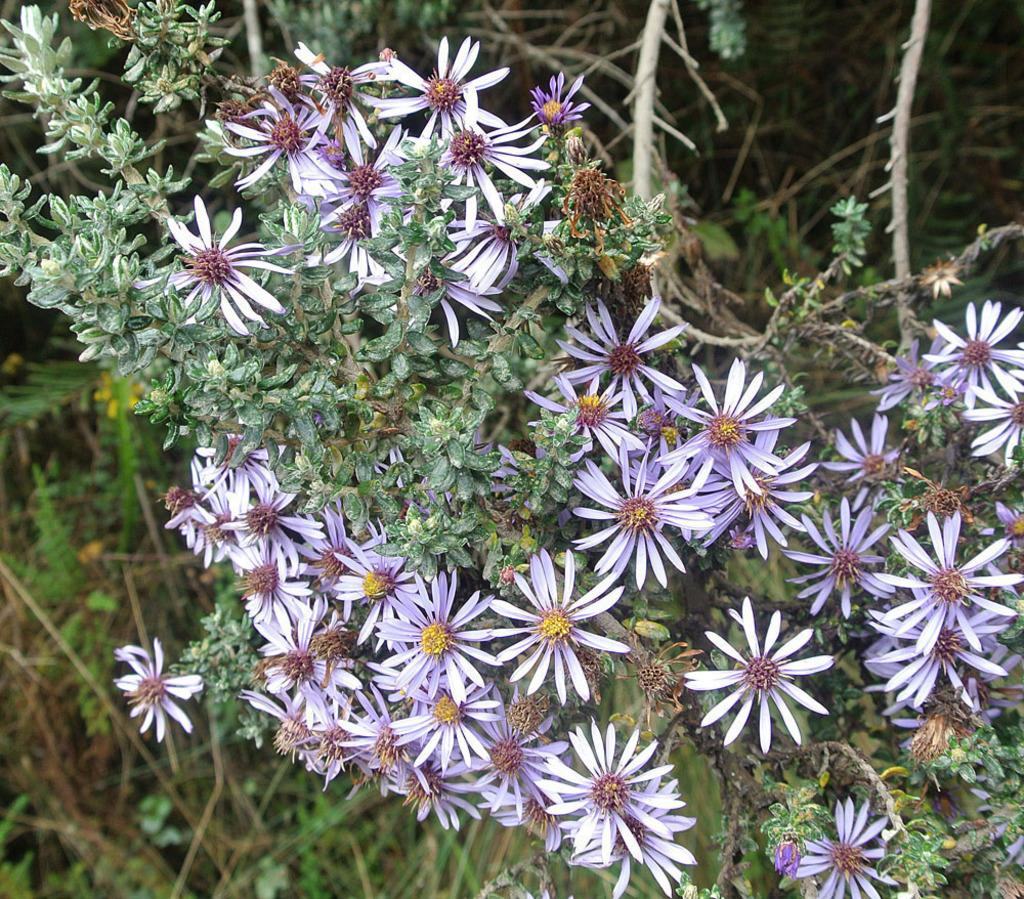What type of vegetation can be seen in the image? There are trees in the image. What colors are the trees in the image? The trees have green and brown colors. What other natural elements can be seen in the image? There are flowers in the image. What colors are the flowers in the image? The flowers have purple and yellow colors. What type of nerve is visible in the image? There is no nerve present in the image; it features trees and flowers. Can you tell me how many pairs of shoes are visible in the image? There are no shoes present in the image. 